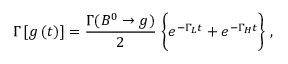<formula> <loc_0><loc_0><loc_500><loc_500>\Gamma \left [ g \left ( t \right ) \right ] = \frac { \Gamma ( B ^ { 0 } \rightarrow g ) } { 2 } \, \left \{ e ^ { - \Gamma _ { L } t } + e ^ { - \Gamma _ { H } t } \right \} \, ,</formula> 